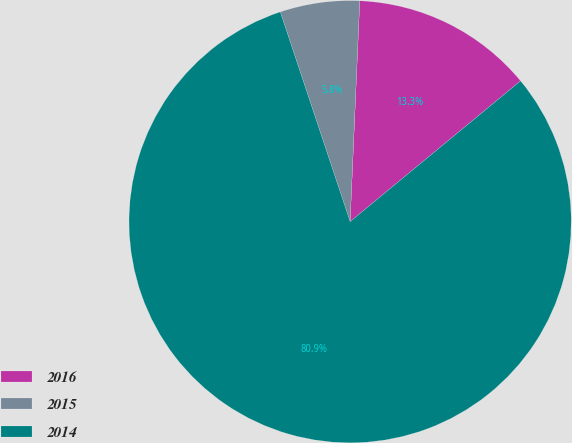Convert chart. <chart><loc_0><loc_0><loc_500><loc_500><pie_chart><fcel>2016<fcel>2015<fcel>2014<nl><fcel>13.32%<fcel>5.81%<fcel>80.87%<nl></chart> 